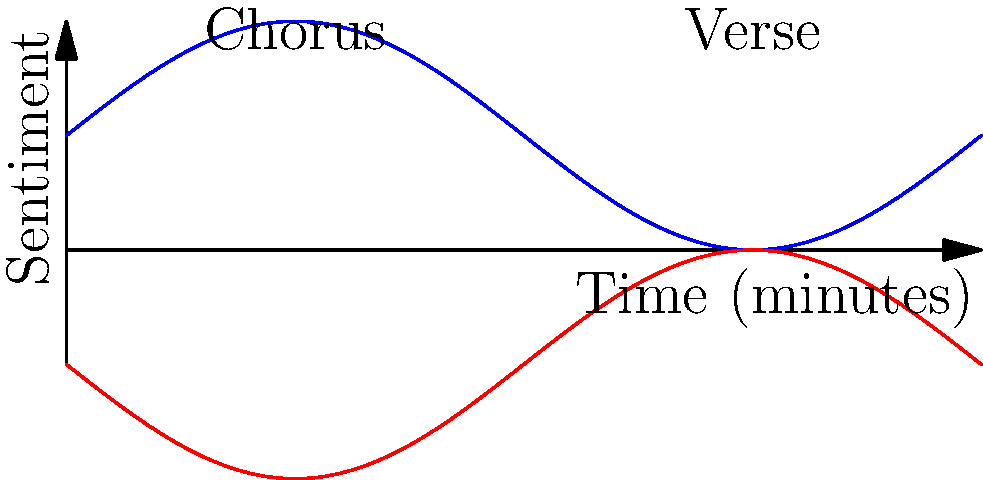As a relationship counselor and country music expert, analyze the sentiment graph of a country song's lyrics. The blue line represents positive sentiment, while the red line represents negative sentiment. What emotional pattern does this graph suggest, and how might it relate to common themes in country music? To analyze this sentiment graph, let's follow these steps:

1. Observe the overall pattern: The graph shows alternating peaks of positive and negative sentiment.

2. Identify key points:
   a. The song starts with a positive sentiment (blue line peaking).
   b. There are two main cycles of sentiment change.
   c. Each cycle has a positive peak followed by a negative peak.

3. Relate to song structure:
   a. The first cycle (0-2 minutes) likely represents the first verse and chorus.
   b. The second cycle (2-4 minutes) probably represents the second verse and chorus.

4. Analyze emotional content:
   a. The positive peaks (chorus) suggest hopeful or uplifting lyrics.
   b. The negative dips (verse) indicate more melancholic or introspective content.

5. Connect to country music themes:
   a. This pattern is common in country songs that contrast hardship with resilience.
   b. Verses often describe struggles (relationship issues, loss, hard times).
   c. Choruses typically offer hope, strength, or resolution.

6. Counseling perspective:
   a. This emotional journey mirrors real-life relationship experiences.
   b. It shows the ups and downs people face and how they find hope despite challenges.

This pattern suggests a song that explores emotional depth, potentially dealing with relationship struggles but ultimately offering a message of hope or perseverance - themes that are central to both country music and relationship counseling.
Answer: Alternating positive (chorus) and negative (verse) sentiments, reflecting country music's theme of finding hope amidst struggles. 